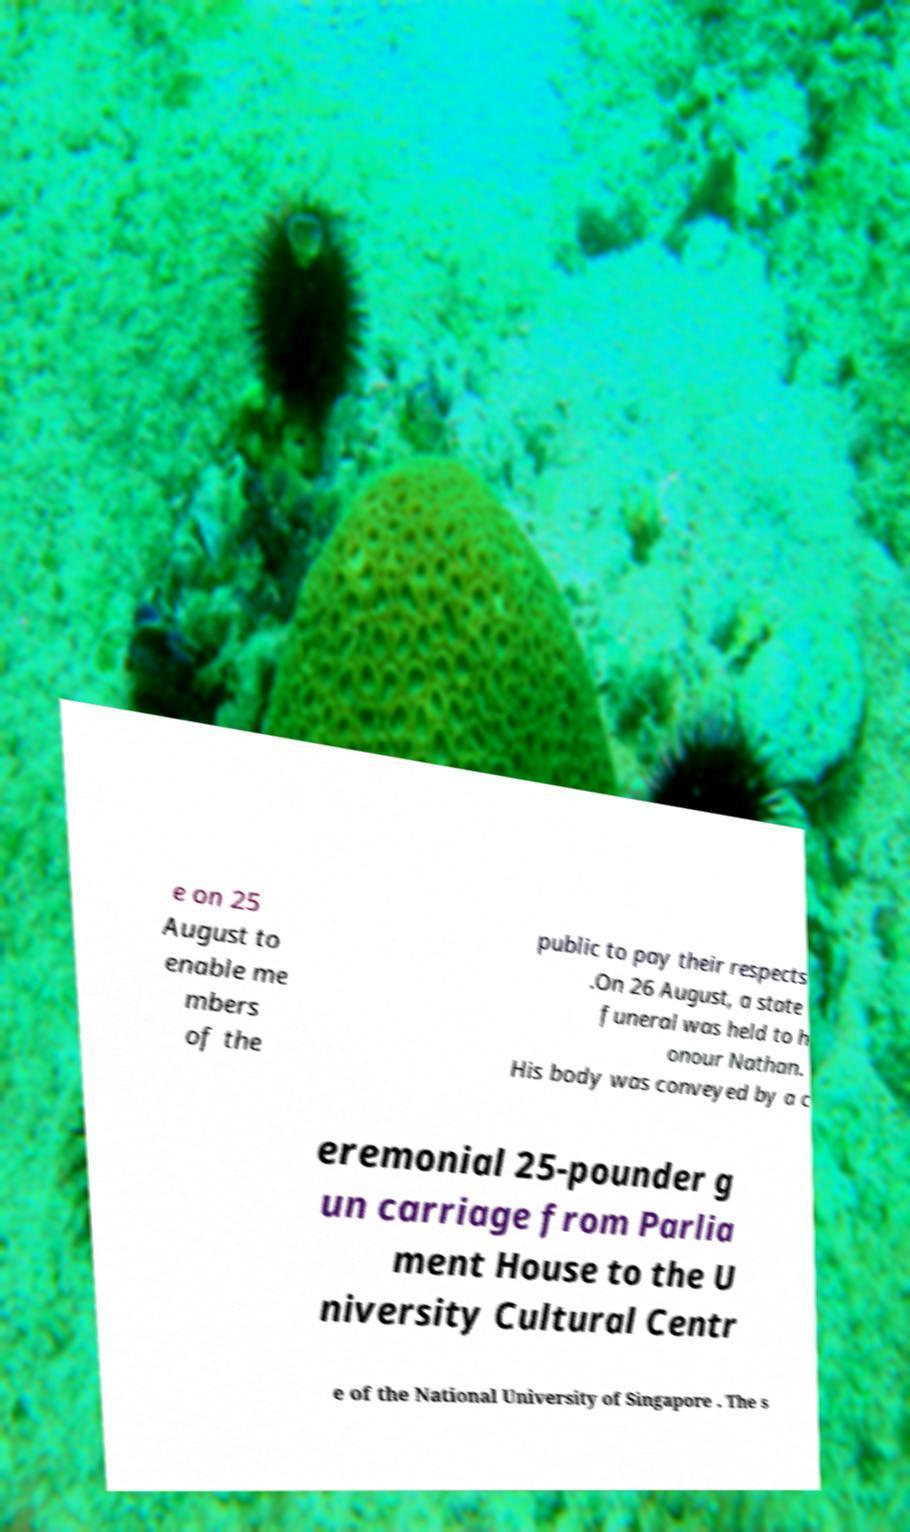I need the written content from this picture converted into text. Can you do that? e on 25 August to enable me mbers of the public to pay their respects .On 26 August, a state funeral was held to h onour Nathan. His body was conveyed by a c eremonial 25-pounder g un carriage from Parlia ment House to the U niversity Cultural Centr e of the National University of Singapore . The s 